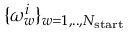Convert formula to latex. <formula><loc_0><loc_0><loc_500><loc_500>\{ \omega _ { w } ^ { i } \} _ { w = 1 , . . , N _ { s t a r t } }</formula> 